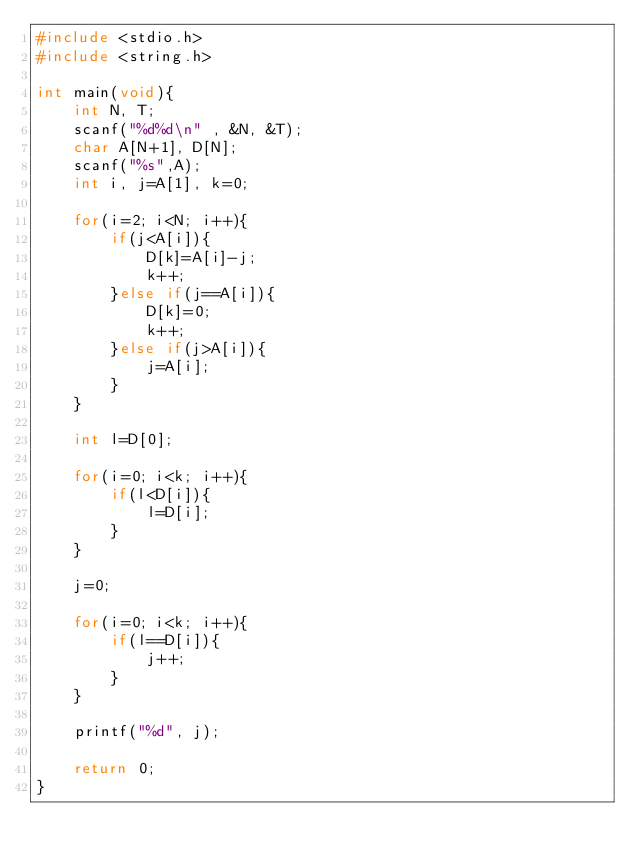<code> <loc_0><loc_0><loc_500><loc_500><_C_>#include <stdio.h>
#include <string.h>

int main(void){
    int N, T;
    scanf("%d%d\n" , &N, &T);
    char A[N+1], D[N];
    scanf("%s",A);
    int i, j=A[1], k=0;

    for(i=2; i<N; i++){
        if(j<A[i]){
            D[k]=A[i]-j;
            k++;
        }else if(j==A[i]){
            D[k]=0;
            k++;
        }else if(j>A[i]){
            j=A[i];
        }
    }
    
    int l=D[0];

    for(i=0; i<k; i++){
        if(l<D[i]){
            l=D[i];
        }
    }

    j=0;

    for(i=0; i<k; i++){
        if(l==D[i]){
            j++;
        }
    }

    printf("%d", j);

    return 0;
}</code> 